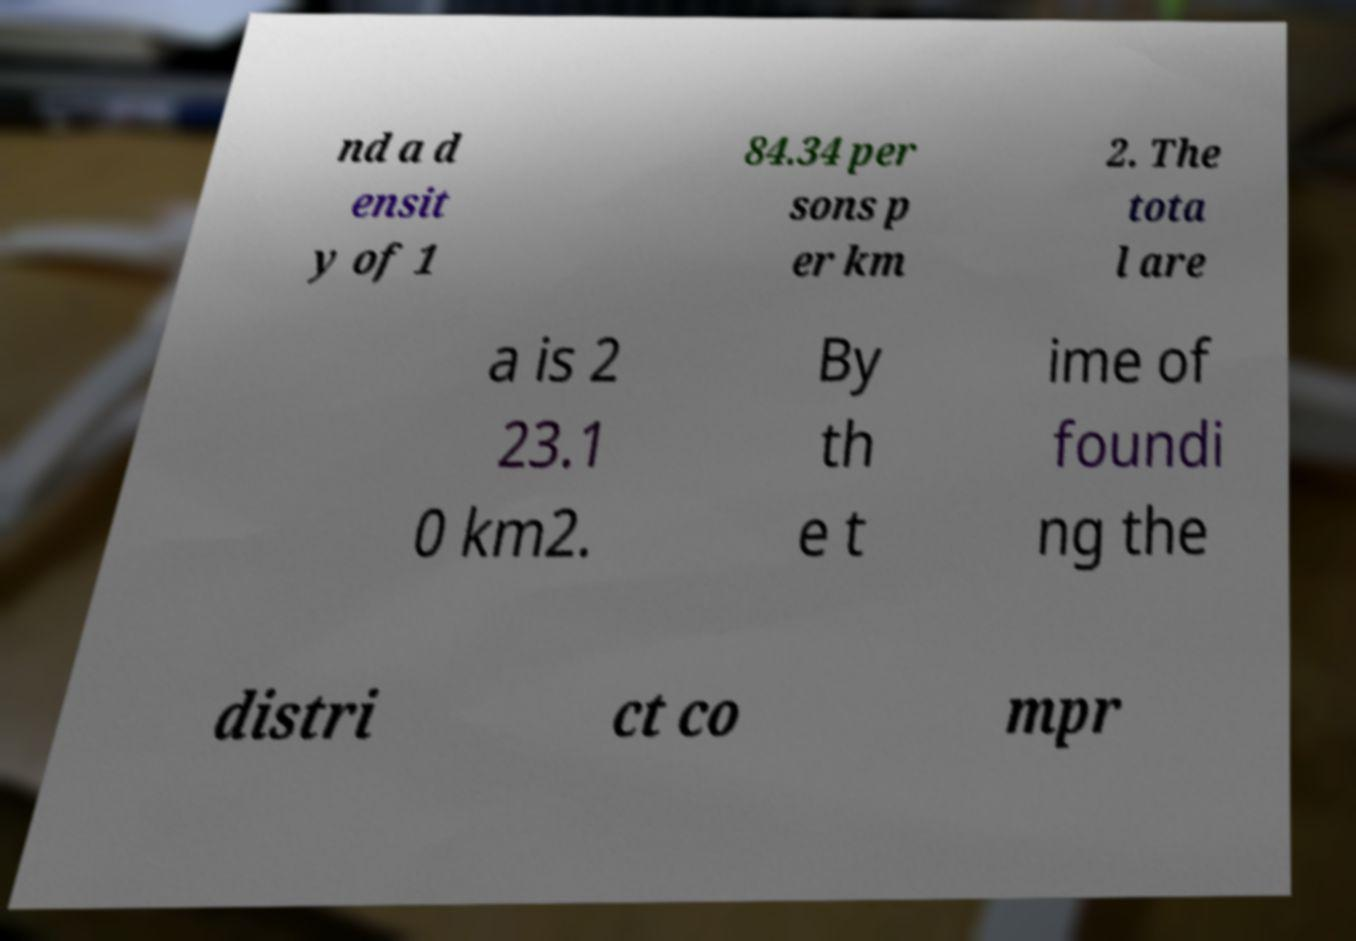Please identify and transcribe the text found in this image. nd a d ensit y of 1 84.34 per sons p er km 2. The tota l are a is 2 23.1 0 km2. By th e t ime of foundi ng the distri ct co mpr 